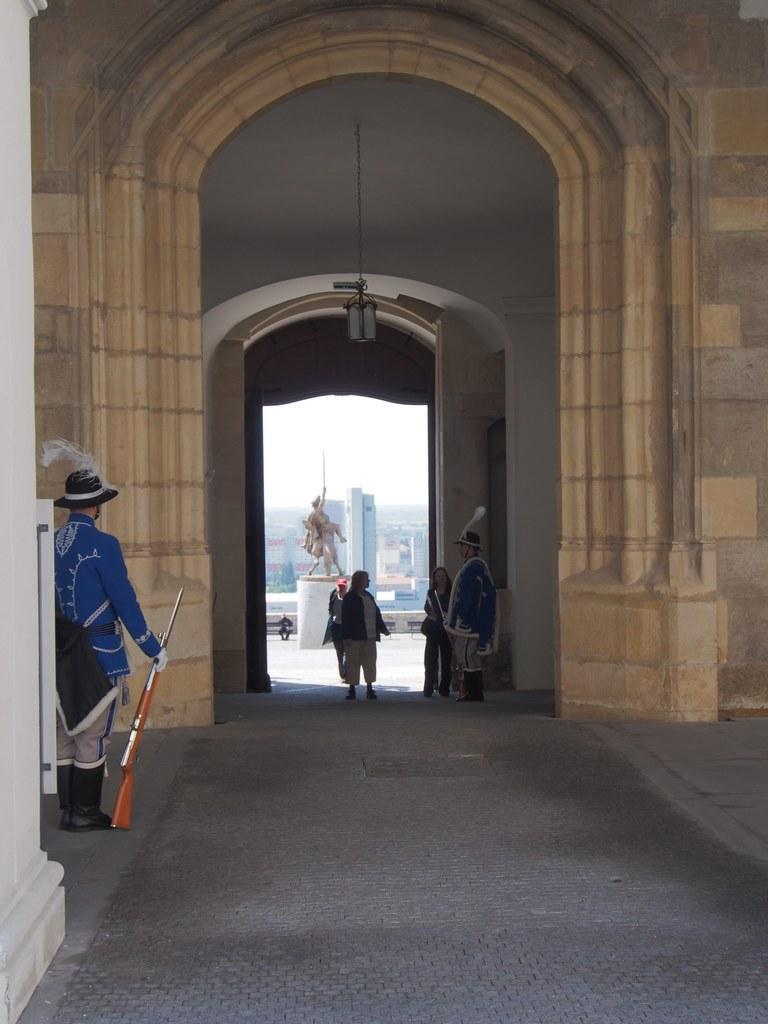In one or two sentences, can you explain what this image depicts? The picture is taken in a castle. On the left there is a soldier and wall. In the center of the picture it is entrance, in the entrance there are people. On the right it is well. In the center of the background there is a sculpture and buildings. It is sunny. 